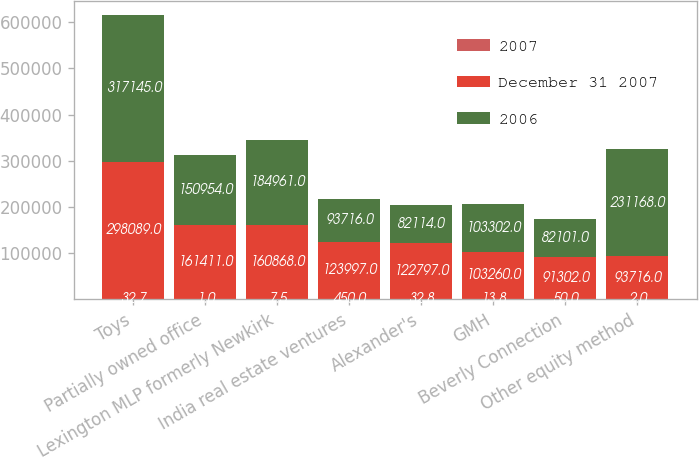Convert chart to OTSL. <chart><loc_0><loc_0><loc_500><loc_500><stacked_bar_chart><ecel><fcel>Toys<fcel>Partially owned office<fcel>Lexington MLP formerly Newkirk<fcel>India real estate ventures<fcel>Alexander's<fcel>GMH<fcel>Beverly Connection<fcel>Other equity method<nl><fcel>2007<fcel>32.7<fcel>1<fcel>7.5<fcel>450<fcel>32.8<fcel>13.8<fcel>50<fcel>2<nl><fcel>December 31 2007<fcel>298089<fcel>161411<fcel>160868<fcel>123997<fcel>122797<fcel>103260<fcel>91302<fcel>93716<nl><fcel>2006<fcel>317145<fcel>150954<fcel>184961<fcel>93716<fcel>82114<fcel>103302<fcel>82101<fcel>231168<nl></chart> 